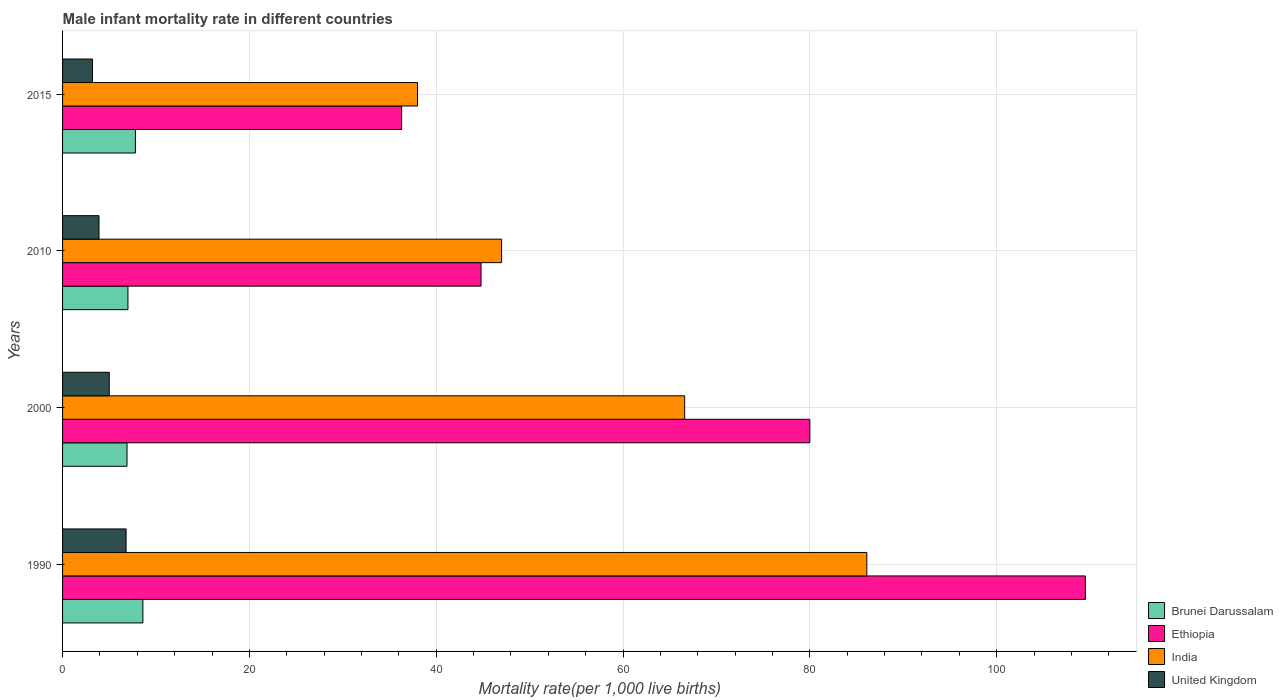How many groups of bars are there?
Your answer should be very brief. 4. Are the number of bars on each tick of the Y-axis equal?
Keep it short and to the point. Yes. How many bars are there on the 2nd tick from the bottom?
Your answer should be compact. 4. What is the label of the 1st group of bars from the top?
Provide a short and direct response. 2015. In how many cases, is the number of bars for a given year not equal to the number of legend labels?
Give a very brief answer. 0. What is the male infant mortality rate in Ethiopia in 2010?
Provide a succinct answer. 44.8. Across all years, what is the maximum male infant mortality rate in Brunei Darussalam?
Make the answer very short. 8.6. In which year was the male infant mortality rate in India minimum?
Provide a short and direct response. 2015. What is the total male infant mortality rate in United Kingdom in the graph?
Your answer should be very brief. 18.9. What is the difference between the male infant mortality rate in United Kingdom in 2000 and that in 2015?
Provide a short and direct response. 1.8. What is the difference between the male infant mortality rate in India in 1990 and the male infant mortality rate in Ethiopia in 2000?
Provide a short and direct response. 6.1. What is the average male infant mortality rate in Brunei Darussalam per year?
Make the answer very short. 7.58. In the year 1990, what is the difference between the male infant mortality rate in India and male infant mortality rate in United Kingdom?
Offer a terse response. 79.3. What is the ratio of the male infant mortality rate in United Kingdom in 1990 to that in 2015?
Offer a terse response. 2.12. Is the difference between the male infant mortality rate in India in 2000 and 2010 greater than the difference between the male infant mortality rate in United Kingdom in 2000 and 2010?
Your response must be concise. Yes. What is the difference between the highest and the second highest male infant mortality rate in United Kingdom?
Make the answer very short. 1.8. What is the difference between the highest and the lowest male infant mortality rate in Ethiopia?
Offer a terse response. 73.2. In how many years, is the male infant mortality rate in Brunei Darussalam greater than the average male infant mortality rate in Brunei Darussalam taken over all years?
Make the answer very short. 2. Is it the case that in every year, the sum of the male infant mortality rate in India and male infant mortality rate in Brunei Darussalam is greater than the sum of male infant mortality rate in Ethiopia and male infant mortality rate in United Kingdom?
Your answer should be compact. Yes. What does the 4th bar from the top in 1990 represents?
Ensure brevity in your answer.  Brunei Darussalam. What does the 1st bar from the bottom in 2000 represents?
Provide a succinct answer. Brunei Darussalam. Is it the case that in every year, the sum of the male infant mortality rate in Ethiopia and male infant mortality rate in India is greater than the male infant mortality rate in Brunei Darussalam?
Provide a succinct answer. Yes. Are all the bars in the graph horizontal?
Keep it short and to the point. Yes. What is the difference between two consecutive major ticks on the X-axis?
Keep it short and to the point. 20. Are the values on the major ticks of X-axis written in scientific E-notation?
Give a very brief answer. No. Does the graph contain any zero values?
Offer a terse response. No. Where does the legend appear in the graph?
Provide a succinct answer. Bottom right. How are the legend labels stacked?
Ensure brevity in your answer.  Vertical. What is the title of the graph?
Your response must be concise. Male infant mortality rate in different countries. Does "United Kingdom" appear as one of the legend labels in the graph?
Your answer should be very brief. Yes. What is the label or title of the X-axis?
Your answer should be compact. Mortality rate(per 1,0 live births). What is the label or title of the Y-axis?
Ensure brevity in your answer.  Years. What is the Mortality rate(per 1,000 live births) of Ethiopia in 1990?
Your answer should be very brief. 109.5. What is the Mortality rate(per 1,000 live births) in India in 1990?
Give a very brief answer. 86.1. What is the Mortality rate(per 1,000 live births) of Brunei Darussalam in 2000?
Your answer should be compact. 6.9. What is the Mortality rate(per 1,000 live births) of India in 2000?
Keep it short and to the point. 66.6. What is the Mortality rate(per 1,000 live births) in Brunei Darussalam in 2010?
Offer a terse response. 7. What is the Mortality rate(per 1,000 live births) in Ethiopia in 2010?
Keep it short and to the point. 44.8. What is the Mortality rate(per 1,000 live births) in United Kingdom in 2010?
Offer a very short reply. 3.9. What is the Mortality rate(per 1,000 live births) of Ethiopia in 2015?
Give a very brief answer. 36.3. What is the Mortality rate(per 1,000 live births) of India in 2015?
Provide a short and direct response. 38. Across all years, what is the maximum Mortality rate(per 1,000 live births) of Ethiopia?
Your response must be concise. 109.5. Across all years, what is the maximum Mortality rate(per 1,000 live births) in India?
Keep it short and to the point. 86.1. Across all years, what is the minimum Mortality rate(per 1,000 live births) in Brunei Darussalam?
Offer a terse response. 6.9. Across all years, what is the minimum Mortality rate(per 1,000 live births) in Ethiopia?
Provide a short and direct response. 36.3. Across all years, what is the minimum Mortality rate(per 1,000 live births) in United Kingdom?
Ensure brevity in your answer.  3.2. What is the total Mortality rate(per 1,000 live births) of Brunei Darussalam in the graph?
Offer a terse response. 30.3. What is the total Mortality rate(per 1,000 live births) of Ethiopia in the graph?
Make the answer very short. 270.6. What is the total Mortality rate(per 1,000 live births) in India in the graph?
Provide a short and direct response. 237.7. What is the difference between the Mortality rate(per 1,000 live births) of Ethiopia in 1990 and that in 2000?
Keep it short and to the point. 29.5. What is the difference between the Mortality rate(per 1,000 live births) in India in 1990 and that in 2000?
Keep it short and to the point. 19.5. What is the difference between the Mortality rate(per 1,000 live births) of Ethiopia in 1990 and that in 2010?
Ensure brevity in your answer.  64.7. What is the difference between the Mortality rate(per 1,000 live births) in India in 1990 and that in 2010?
Offer a terse response. 39.1. What is the difference between the Mortality rate(per 1,000 live births) in United Kingdom in 1990 and that in 2010?
Offer a very short reply. 2.9. What is the difference between the Mortality rate(per 1,000 live births) of Ethiopia in 1990 and that in 2015?
Your answer should be very brief. 73.2. What is the difference between the Mortality rate(per 1,000 live births) of India in 1990 and that in 2015?
Your response must be concise. 48.1. What is the difference between the Mortality rate(per 1,000 live births) in United Kingdom in 1990 and that in 2015?
Your answer should be very brief. 3.6. What is the difference between the Mortality rate(per 1,000 live births) in Ethiopia in 2000 and that in 2010?
Offer a very short reply. 35.2. What is the difference between the Mortality rate(per 1,000 live births) in India in 2000 and that in 2010?
Keep it short and to the point. 19.6. What is the difference between the Mortality rate(per 1,000 live births) of United Kingdom in 2000 and that in 2010?
Your answer should be compact. 1.1. What is the difference between the Mortality rate(per 1,000 live births) in Brunei Darussalam in 2000 and that in 2015?
Give a very brief answer. -0.9. What is the difference between the Mortality rate(per 1,000 live births) of Ethiopia in 2000 and that in 2015?
Provide a succinct answer. 43.7. What is the difference between the Mortality rate(per 1,000 live births) in India in 2000 and that in 2015?
Give a very brief answer. 28.6. What is the difference between the Mortality rate(per 1,000 live births) of United Kingdom in 2000 and that in 2015?
Ensure brevity in your answer.  1.8. What is the difference between the Mortality rate(per 1,000 live births) in Brunei Darussalam in 2010 and that in 2015?
Your answer should be compact. -0.8. What is the difference between the Mortality rate(per 1,000 live births) of India in 2010 and that in 2015?
Ensure brevity in your answer.  9. What is the difference between the Mortality rate(per 1,000 live births) of Brunei Darussalam in 1990 and the Mortality rate(per 1,000 live births) of Ethiopia in 2000?
Your answer should be very brief. -71.4. What is the difference between the Mortality rate(per 1,000 live births) of Brunei Darussalam in 1990 and the Mortality rate(per 1,000 live births) of India in 2000?
Offer a terse response. -58. What is the difference between the Mortality rate(per 1,000 live births) of Brunei Darussalam in 1990 and the Mortality rate(per 1,000 live births) of United Kingdom in 2000?
Make the answer very short. 3.6. What is the difference between the Mortality rate(per 1,000 live births) of Ethiopia in 1990 and the Mortality rate(per 1,000 live births) of India in 2000?
Give a very brief answer. 42.9. What is the difference between the Mortality rate(per 1,000 live births) of Ethiopia in 1990 and the Mortality rate(per 1,000 live births) of United Kingdom in 2000?
Your answer should be very brief. 104.5. What is the difference between the Mortality rate(per 1,000 live births) in India in 1990 and the Mortality rate(per 1,000 live births) in United Kingdom in 2000?
Give a very brief answer. 81.1. What is the difference between the Mortality rate(per 1,000 live births) in Brunei Darussalam in 1990 and the Mortality rate(per 1,000 live births) in Ethiopia in 2010?
Make the answer very short. -36.2. What is the difference between the Mortality rate(per 1,000 live births) of Brunei Darussalam in 1990 and the Mortality rate(per 1,000 live births) of India in 2010?
Your response must be concise. -38.4. What is the difference between the Mortality rate(per 1,000 live births) in Ethiopia in 1990 and the Mortality rate(per 1,000 live births) in India in 2010?
Your answer should be very brief. 62.5. What is the difference between the Mortality rate(per 1,000 live births) in Ethiopia in 1990 and the Mortality rate(per 1,000 live births) in United Kingdom in 2010?
Offer a terse response. 105.6. What is the difference between the Mortality rate(per 1,000 live births) of India in 1990 and the Mortality rate(per 1,000 live births) of United Kingdom in 2010?
Ensure brevity in your answer.  82.2. What is the difference between the Mortality rate(per 1,000 live births) of Brunei Darussalam in 1990 and the Mortality rate(per 1,000 live births) of Ethiopia in 2015?
Provide a short and direct response. -27.7. What is the difference between the Mortality rate(per 1,000 live births) of Brunei Darussalam in 1990 and the Mortality rate(per 1,000 live births) of India in 2015?
Give a very brief answer. -29.4. What is the difference between the Mortality rate(per 1,000 live births) in Brunei Darussalam in 1990 and the Mortality rate(per 1,000 live births) in United Kingdom in 2015?
Your response must be concise. 5.4. What is the difference between the Mortality rate(per 1,000 live births) in Ethiopia in 1990 and the Mortality rate(per 1,000 live births) in India in 2015?
Offer a terse response. 71.5. What is the difference between the Mortality rate(per 1,000 live births) of Ethiopia in 1990 and the Mortality rate(per 1,000 live births) of United Kingdom in 2015?
Your answer should be compact. 106.3. What is the difference between the Mortality rate(per 1,000 live births) in India in 1990 and the Mortality rate(per 1,000 live births) in United Kingdom in 2015?
Offer a very short reply. 82.9. What is the difference between the Mortality rate(per 1,000 live births) of Brunei Darussalam in 2000 and the Mortality rate(per 1,000 live births) of Ethiopia in 2010?
Your answer should be compact. -37.9. What is the difference between the Mortality rate(per 1,000 live births) of Brunei Darussalam in 2000 and the Mortality rate(per 1,000 live births) of India in 2010?
Provide a short and direct response. -40.1. What is the difference between the Mortality rate(per 1,000 live births) in Brunei Darussalam in 2000 and the Mortality rate(per 1,000 live births) in United Kingdom in 2010?
Your answer should be very brief. 3. What is the difference between the Mortality rate(per 1,000 live births) of Ethiopia in 2000 and the Mortality rate(per 1,000 live births) of India in 2010?
Offer a terse response. 33. What is the difference between the Mortality rate(per 1,000 live births) in Ethiopia in 2000 and the Mortality rate(per 1,000 live births) in United Kingdom in 2010?
Provide a succinct answer. 76.1. What is the difference between the Mortality rate(per 1,000 live births) of India in 2000 and the Mortality rate(per 1,000 live births) of United Kingdom in 2010?
Make the answer very short. 62.7. What is the difference between the Mortality rate(per 1,000 live births) in Brunei Darussalam in 2000 and the Mortality rate(per 1,000 live births) in Ethiopia in 2015?
Your answer should be compact. -29.4. What is the difference between the Mortality rate(per 1,000 live births) in Brunei Darussalam in 2000 and the Mortality rate(per 1,000 live births) in India in 2015?
Keep it short and to the point. -31.1. What is the difference between the Mortality rate(per 1,000 live births) in Brunei Darussalam in 2000 and the Mortality rate(per 1,000 live births) in United Kingdom in 2015?
Give a very brief answer. 3.7. What is the difference between the Mortality rate(per 1,000 live births) of Ethiopia in 2000 and the Mortality rate(per 1,000 live births) of India in 2015?
Your answer should be very brief. 42. What is the difference between the Mortality rate(per 1,000 live births) of Ethiopia in 2000 and the Mortality rate(per 1,000 live births) of United Kingdom in 2015?
Make the answer very short. 76.8. What is the difference between the Mortality rate(per 1,000 live births) of India in 2000 and the Mortality rate(per 1,000 live births) of United Kingdom in 2015?
Give a very brief answer. 63.4. What is the difference between the Mortality rate(per 1,000 live births) in Brunei Darussalam in 2010 and the Mortality rate(per 1,000 live births) in Ethiopia in 2015?
Your answer should be very brief. -29.3. What is the difference between the Mortality rate(per 1,000 live births) in Brunei Darussalam in 2010 and the Mortality rate(per 1,000 live births) in India in 2015?
Provide a succinct answer. -31. What is the difference between the Mortality rate(per 1,000 live births) in Ethiopia in 2010 and the Mortality rate(per 1,000 live births) in India in 2015?
Offer a terse response. 6.8. What is the difference between the Mortality rate(per 1,000 live births) in Ethiopia in 2010 and the Mortality rate(per 1,000 live births) in United Kingdom in 2015?
Give a very brief answer. 41.6. What is the difference between the Mortality rate(per 1,000 live births) in India in 2010 and the Mortality rate(per 1,000 live births) in United Kingdom in 2015?
Your answer should be compact. 43.8. What is the average Mortality rate(per 1,000 live births) of Brunei Darussalam per year?
Your answer should be compact. 7.58. What is the average Mortality rate(per 1,000 live births) in Ethiopia per year?
Provide a short and direct response. 67.65. What is the average Mortality rate(per 1,000 live births) of India per year?
Provide a succinct answer. 59.42. What is the average Mortality rate(per 1,000 live births) of United Kingdom per year?
Provide a succinct answer. 4.72. In the year 1990, what is the difference between the Mortality rate(per 1,000 live births) of Brunei Darussalam and Mortality rate(per 1,000 live births) of Ethiopia?
Your answer should be compact. -100.9. In the year 1990, what is the difference between the Mortality rate(per 1,000 live births) of Brunei Darussalam and Mortality rate(per 1,000 live births) of India?
Give a very brief answer. -77.5. In the year 1990, what is the difference between the Mortality rate(per 1,000 live births) in Ethiopia and Mortality rate(per 1,000 live births) in India?
Offer a terse response. 23.4. In the year 1990, what is the difference between the Mortality rate(per 1,000 live births) in Ethiopia and Mortality rate(per 1,000 live births) in United Kingdom?
Your response must be concise. 102.7. In the year 1990, what is the difference between the Mortality rate(per 1,000 live births) in India and Mortality rate(per 1,000 live births) in United Kingdom?
Offer a very short reply. 79.3. In the year 2000, what is the difference between the Mortality rate(per 1,000 live births) in Brunei Darussalam and Mortality rate(per 1,000 live births) in Ethiopia?
Your response must be concise. -73.1. In the year 2000, what is the difference between the Mortality rate(per 1,000 live births) of Brunei Darussalam and Mortality rate(per 1,000 live births) of India?
Offer a very short reply. -59.7. In the year 2000, what is the difference between the Mortality rate(per 1,000 live births) of Brunei Darussalam and Mortality rate(per 1,000 live births) of United Kingdom?
Make the answer very short. 1.9. In the year 2000, what is the difference between the Mortality rate(per 1,000 live births) of India and Mortality rate(per 1,000 live births) of United Kingdom?
Your answer should be compact. 61.6. In the year 2010, what is the difference between the Mortality rate(per 1,000 live births) in Brunei Darussalam and Mortality rate(per 1,000 live births) in Ethiopia?
Provide a short and direct response. -37.8. In the year 2010, what is the difference between the Mortality rate(per 1,000 live births) in Brunei Darussalam and Mortality rate(per 1,000 live births) in India?
Ensure brevity in your answer.  -40. In the year 2010, what is the difference between the Mortality rate(per 1,000 live births) in Ethiopia and Mortality rate(per 1,000 live births) in India?
Offer a terse response. -2.2. In the year 2010, what is the difference between the Mortality rate(per 1,000 live births) in Ethiopia and Mortality rate(per 1,000 live births) in United Kingdom?
Offer a terse response. 40.9. In the year 2010, what is the difference between the Mortality rate(per 1,000 live births) in India and Mortality rate(per 1,000 live births) in United Kingdom?
Make the answer very short. 43.1. In the year 2015, what is the difference between the Mortality rate(per 1,000 live births) of Brunei Darussalam and Mortality rate(per 1,000 live births) of Ethiopia?
Your response must be concise. -28.5. In the year 2015, what is the difference between the Mortality rate(per 1,000 live births) in Brunei Darussalam and Mortality rate(per 1,000 live births) in India?
Offer a very short reply. -30.2. In the year 2015, what is the difference between the Mortality rate(per 1,000 live births) in Brunei Darussalam and Mortality rate(per 1,000 live births) in United Kingdom?
Your response must be concise. 4.6. In the year 2015, what is the difference between the Mortality rate(per 1,000 live births) in Ethiopia and Mortality rate(per 1,000 live births) in United Kingdom?
Your response must be concise. 33.1. In the year 2015, what is the difference between the Mortality rate(per 1,000 live births) of India and Mortality rate(per 1,000 live births) of United Kingdom?
Offer a terse response. 34.8. What is the ratio of the Mortality rate(per 1,000 live births) of Brunei Darussalam in 1990 to that in 2000?
Provide a short and direct response. 1.25. What is the ratio of the Mortality rate(per 1,000 live births) in Ethiopia in 1990 to that in 2000?
Keep it short and to the point. 1.37. What is the ratio of the Mortality rate(per 1,000 live births) of India in 1990 to that in 2000?
Give a very brief answer. 1.29. What is the ratio of the Mortality rate(per 1,000 live births) of United Kingdom in 1990 to that in 2000?
Your answer should be compact. 1.36. What is the ratio of the Mortality rate(per 1,000 live births) of Brunei Darussalam in 1990 to that in 2010?
Offer a very short reply. 1.23. What is the ratio of the Mortality rate(per 1,000 live births) in Ethiopia in 1990 to that in 2010?
Your response must be concise. 2.44. What is the ratio of the Mortality rate(per 1,000 live births) in India in 1990 to that in 2010?
Keep it short and to the point. 1.83. What is the ratio of the Mortality rate(per 1,000 live births) in United Kingdom in 1990 to that in 2010?
Make the answer very short. 1.74. What is the ratio of the Mortality rate(per 1,000 live births) in Brunei Darussalam in 1990 to that in 2015?
Make the answer very short. 1.1. What is the ratio of the Mortality rate(per 1,000 live births) in Ethiopia in 1990 to that in 2015?
Offer a very short reply. 3.02. What is the ratio of the Mortality rate(per 1,000 live births) of India in 1990 to that in 2015?
Keep it short and to the point. 2.27. What is the ratio of the Mortality rate(per 1,000 live births) in United Kingdom in 1990 to that in 2015?
Your answer should be compact. 2.12. What is the ratio of the Mortality rate(per 1,000 live births) in Brunei Darussalam in 2000 to that in 2010?
Keep it short and to the point. 0.99. What is the ratio of the Mortality rate(per 1,000 live births) in Ethiopia in 2000 to that in 2010?
Your answer should be very brief. 1.79. What is the ratio of the Mortality rate(per 1,000 live births) in India in 2000 to that in 2010?
Give a very brief answer. 1.42. What is the ratio of the Mortality rate(per 1,000 live births) of United Kingdom in 2000 to that in 2010?
Offer a terse response. 1.28. What is the ratio of the Mortality rate(per 1,000 live births) in Brunei Darussalam in 2000 to that in 2015?
Provide a succinct answer. 0.88. What is the ratio of the Mortality rate(per 1,000 live births) of Ethiopia in 2000 to that in 2015?
Ensure brevity in your answer.  2.2. What is the ratio of the Mortality rate(per 1,000 live births) of India in 2000 to that in 2015?
Keep it short and to the point. 1.75. What is the ratio of the Mortality rate(per 1,000 live births) of United Kingdom in 2000 to that in 2015?
Keep it short and to the point. 1.56. What is the ratio of the Mortality rate(per 1,000 live births) of Brunei Darussalam in 2010 to that in 2015?
Offer a terse response. 0.9. What is the ratio of the Mortality rate(per 1,000 live births) in Ethiopia in 2010 to that in 2015?
Ensure brevity in your answer.  1.23. What is the ratio of the Mortality rate(per 1,000 live births) of India in 2010 to that in 2015?
Provide a succinct answer. 1.24. What is the ratio of the Mortality rate(per 1,000 live births) in United Kingdom in 2010 to that in 2015?
Offer a very short reply. 1.22. What is the difference between the highest and the second highest Mortality rate(per 1,000 live births) of Ethiopia?
Your answer should be very brief. 29.5. What is the difference between the highest and the second highest Mortality rate(per 1,000 live births) of India?
Provide a succinct answer. 19.5. What is the difference between the highest and the second highest Mortality rate(per 1,000 live births) of United Kingdom?
Offer a terse response. 1.8. What is the difference between the highest and the lowest Mortality rate(per 1,000 live births) of Ethiopia?
Your answer should be compact. 73.2. What is the difference between the highest and the lowest Mortality rate(per 1,000 live births) in India?
Your answer should be very brief. 48.1. 